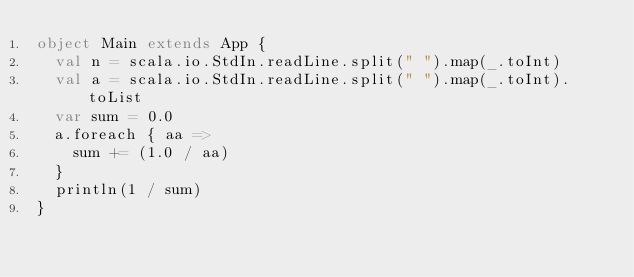Convert code to text. <code><loc_0><loc_0><loc_500><loc_500><_Scala_>object Main extends App {
  val n = scala.io.StdIn.readLine.split(" ").map(_.toInt)
  val a = scala.io.StdIn.readLine.split(" ").map(_.toInt).toList
  var sum = 0.0
  a.foreach { aa =>
    sum += (1.0 / aa)
  }
  println(1 / sum)
}
</code> 